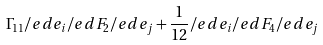Convert formula to latex. <formula><loc_0><loc_0><loc_500><loc_500>\Gamma _ { 1 1 } \slash e d { e } _ { i } \slash e d { F } _ { 2 } \slash e d { e } _ { j } + \frac { 1 } { 1 2 } \slash e d { e } _ { i } \slash e d { F } _ { 4 } \slash e d { e } _ { j }</formula> 